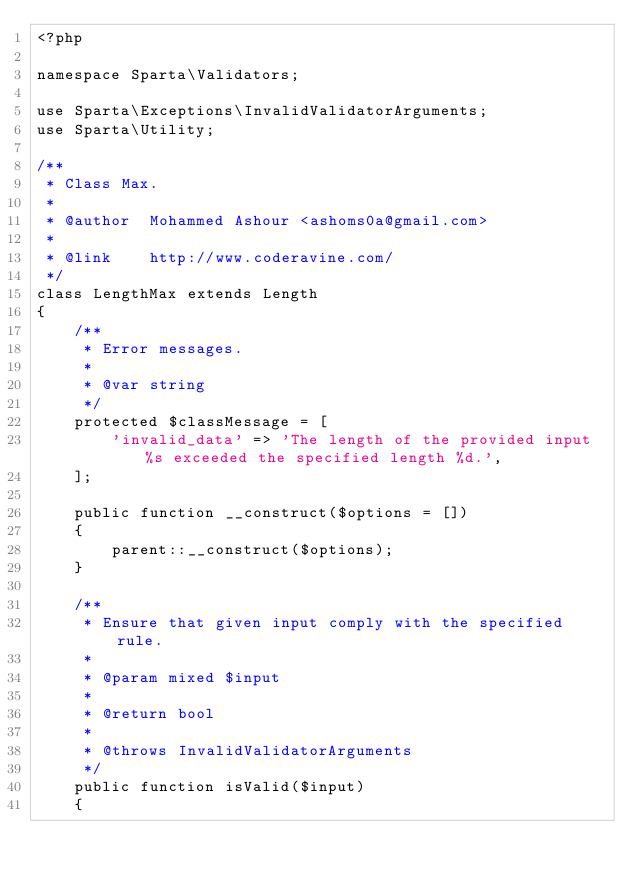<code> <loc_0><loc_0><loc_500><loc_500><_PHP_><?php

namespace Sparta\Validators;

use Sparta\Exceptions\InvalidValidatorArguments;
use Sparta\Utility;

/**
 * Class Max.
 *
 * @author  Mohammed Ashour <ashoms0a@gmail.com>
 *
 * @link    http://www.coderavine.com/
 */
class LengthMax extends Length
{
    /**
     * Error messages.
     *
     * @var string
     */
    protected $classMessage = [
        'invalid_data' => 'The length of the provided input %s exceeded the specified length %d.',
    ];

    public function __construct($options = [])
    {
        parent::__construct($options);
    }

    /**
     * Ensure that given input comply with the specified rule.
     *
     * @param mixed $input
     *
     * @return bool
     *
     * @throws InvalidValidatorArguments
     */
    public function isValid($input)
    {</code> 